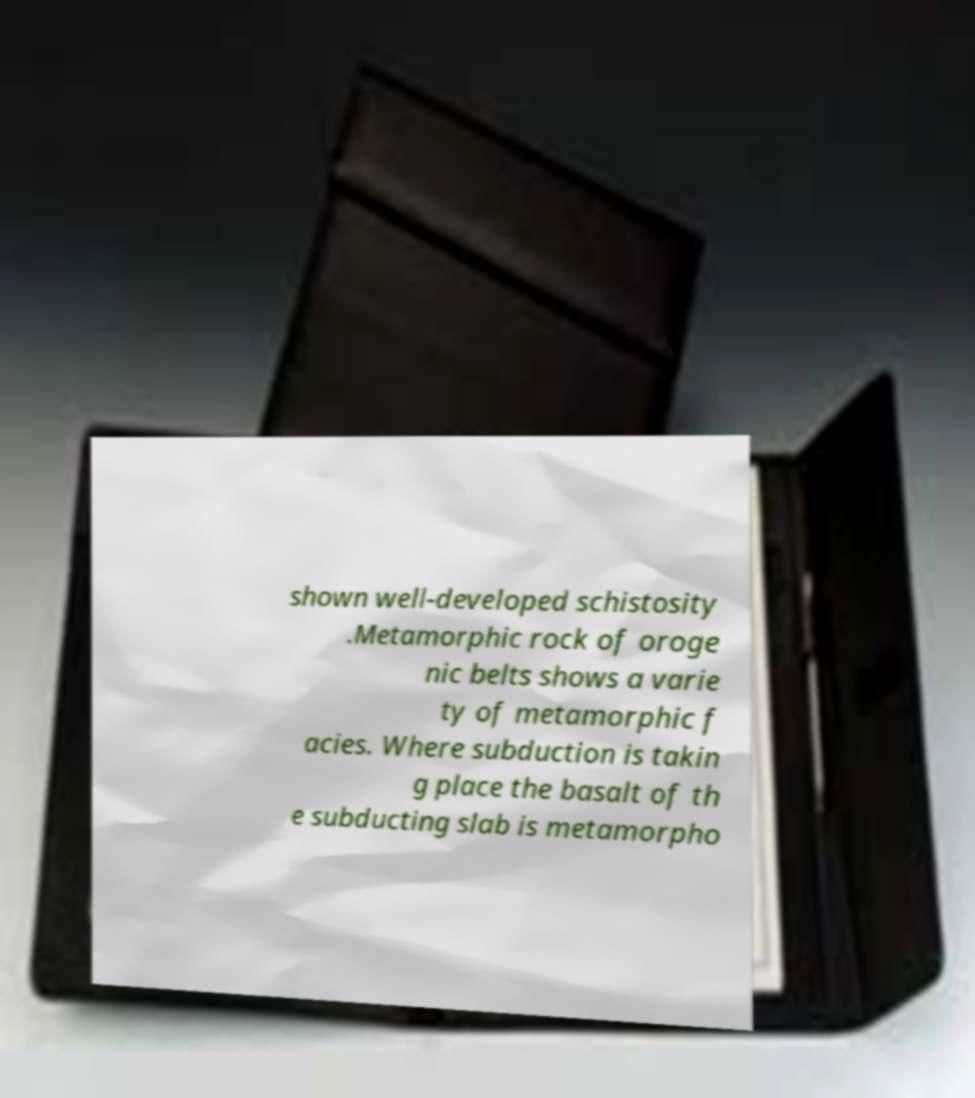Please identify and transcribe the text found in this image. shown well-developed schistosity .Metamorphic rock of oroge nic belts shows a varie ty of metamorphic f acies. Where subduction is takin g place the basalt of th e subducting slab is metamorpho 